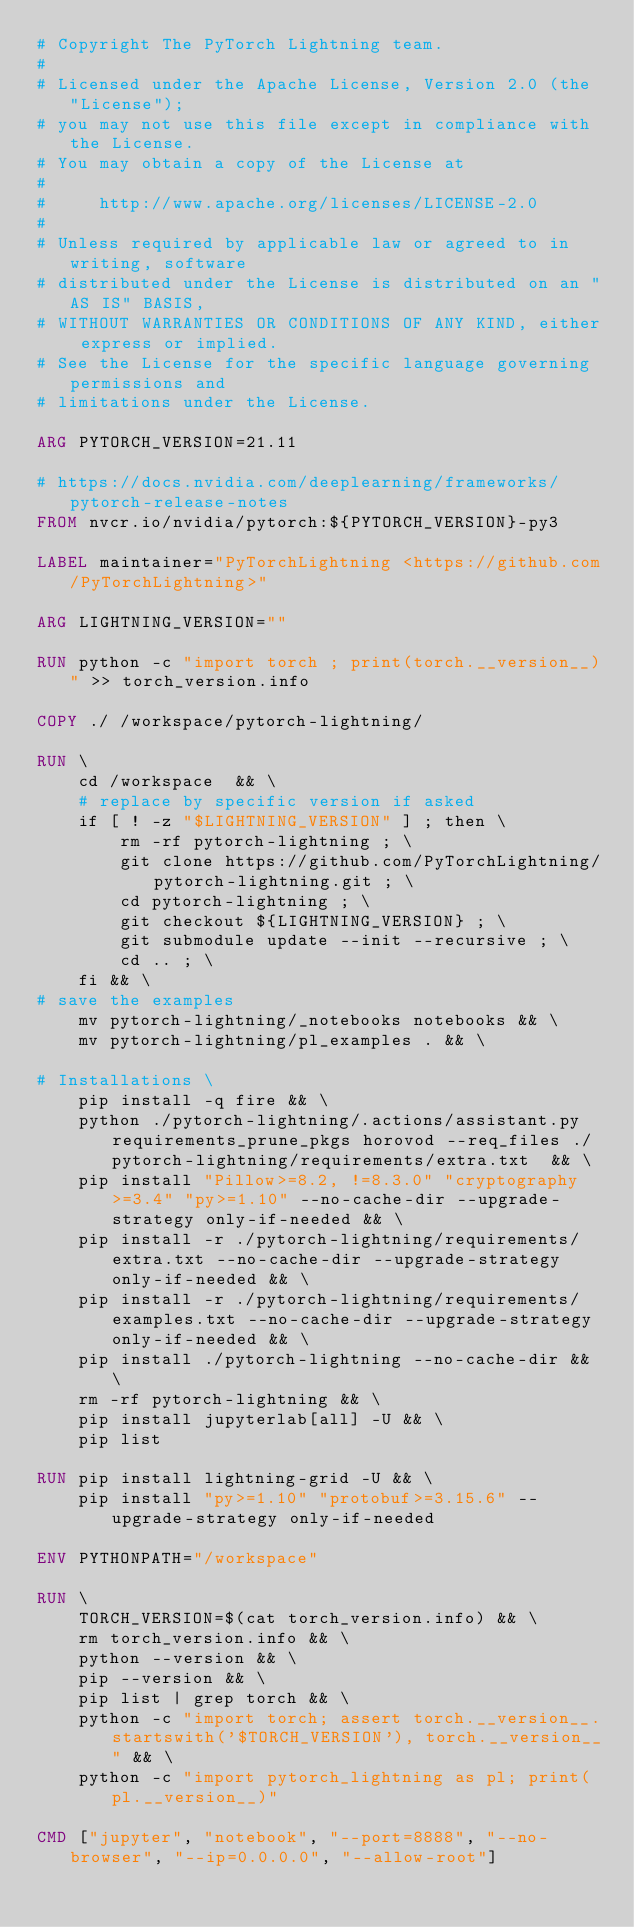Convert code to text. <code><loc_0><loc_0><loc_500><loc_500><_Dockerfile_># Copyright The PyTorch Lightning team.
#
# Licensed under the Apache License, Version 2.0 (the "License");
# you may not use this file except in compliance with the License.
# You may obtain a copy of the License at
#
#     http://www.apache.org/licenses/LICENSE-2.0
#
# Unless required by applicable law or agreed to in writing, software
# distributed under the License is distributed on an "AS IS" BASIS,
# WITHOUT WARRANTIES OR CONDITIONS OF ANY KIND, either express or implied.
# See the License for the specific language governing permissions and
# limitations under the License.

ARG PYTORCH_VERSION=21.11

# https://docs.nvidia.com/deeplearning/frameworks/pytorch-release-notes
FROM nvcr.io/nvidia/pytorch:${PYTORCH_VERSION}-py3

LABEL maintainer="PyTorchLightning <https://github.com/PyTorchLightning>"

ARG LIGHTNING_VERSION=""

RUN python -c "import torch ; print(torch.__version__)" >> torch_version.info

COPY ./ /workspace/pytorch-lightning/

RUN \
    cd /workspace  && \
    # replace by specific version if asked
    if [ ! -z "$LIGHTNING_VERSION" ] ; then \
        rm -rf pytorch-lightning ; \
        git clone https://github.com/PyTorchLightning/pytorch-lightning.git ; \
        cd pytorch-lightning ; \
        git checkout ${LIGHTNING_VERSION} ; \
        git submodule update --init --recursive ; \
        cd .. ; \
    fi && \
# save the examples
    mv pytorch-lightning/_notebooks notebooks && \
    mv pytorch-lightning/pl_examples . && \

# Installations \
    pip install -q fire && \
    python ./pytorch-lightning/.actions/assistant.py requirements_prune_pkgs horovod --req_files ./pytorch-lightning/requirements/extra.txt  && \
    pip install "Pillow>=8.2, !=8.3.0" "cryptography>=3.4" "py>=1.10" --no-cache-dir --upgrade-strategy only-if-needed && \
    pip install -r ./pytorch-lightning/requirements/extra.txt --no-cache-dir --upgrade-strategy only-if-needed && \
    pip install -r ./pytorch-lightning/requirements/examples.txt --no-cache-dir --upgrade-strategy only-if-needed && \
    pip install ./pytorch-lightning --no-cache-dir && \
    rm -rf pytorch-lightning && \
    pip install jupyterlab[all] -U && \
    pip list

RUN pip install lightning-grid -U && \
    pip install "py>=1.10" "protobuf>=3.15.6" --upgrade-strategy only-if-needed

ENV PYTHONPATH="/workspace"

RUN \
    TORCH_VERSION=$(cat torch_version.info) && \
    rm torch_version.info && \
    python --version && \
    pip --version && \
    pip list | grep torch && \
    python -c "import torch; assert torch.__version__.startswith('$TORCH_VERSION'), torch.__version__" && \
    python -c "import pytorch_lightning as pl; print(pl.__version__)"

CMD ["jupyter", "notebook", "--port=8888", "--no-browser", "--ip=0.0.0.0", "--allow-root"]
</code> 